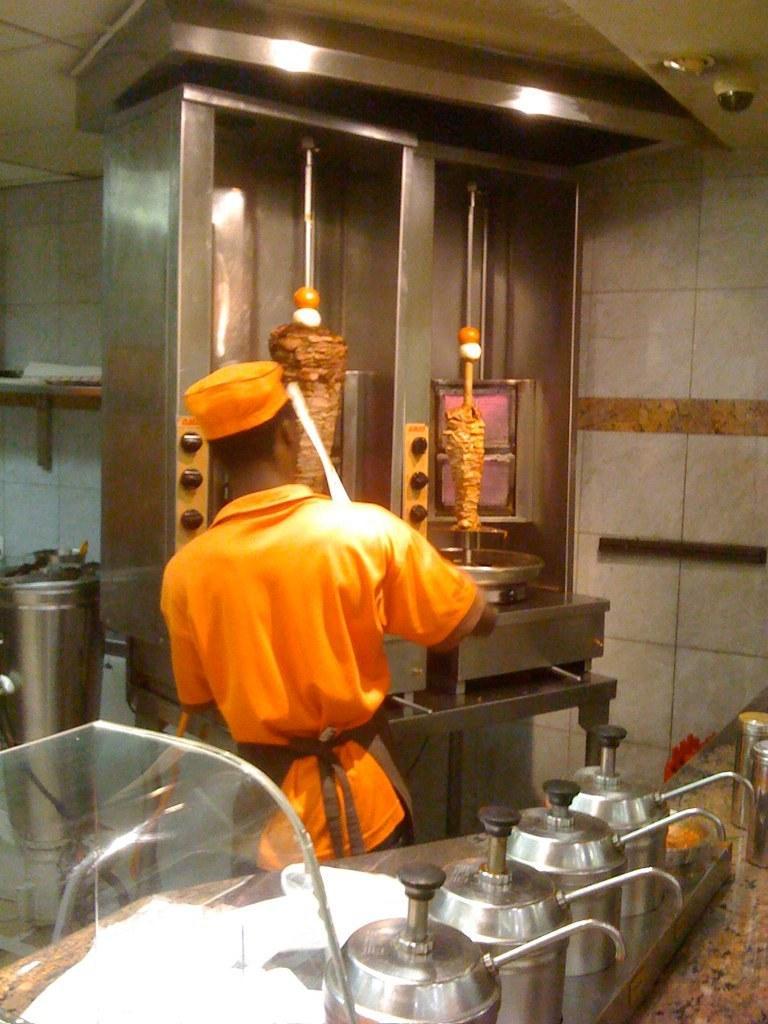Please provide a concise description of this image. In the center of the image there is a person standing at the grilling machine. At the bottom of the image we can see kettles, counter top. In the background there is a wall. 